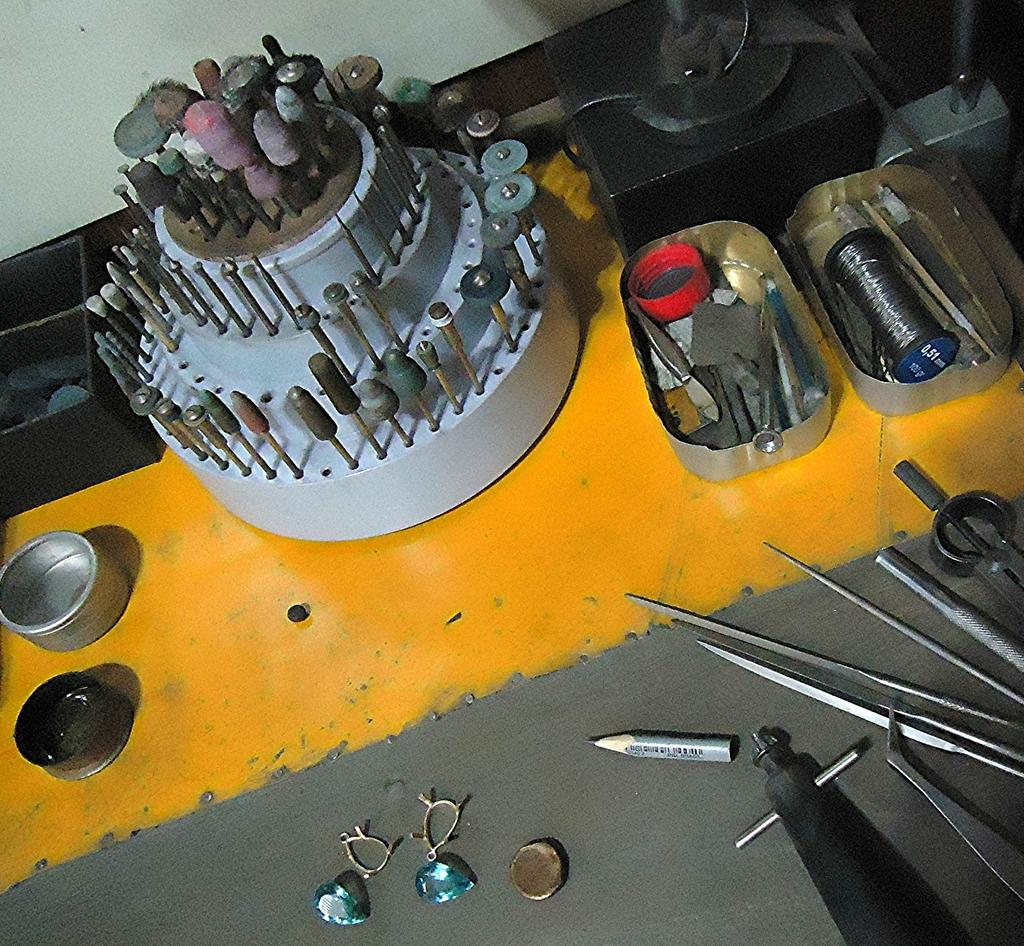What type of items are in the boxes in the image? There are boxes with tools in the image. What else can be seen in the image besides the boxes with tools? There are other tools and objects in the image. What is visible in the background of the image? There is a wall in the background of the image. What is the price of the tank in the image? There is no tank present in the image, so it is not possible to determine its price. 